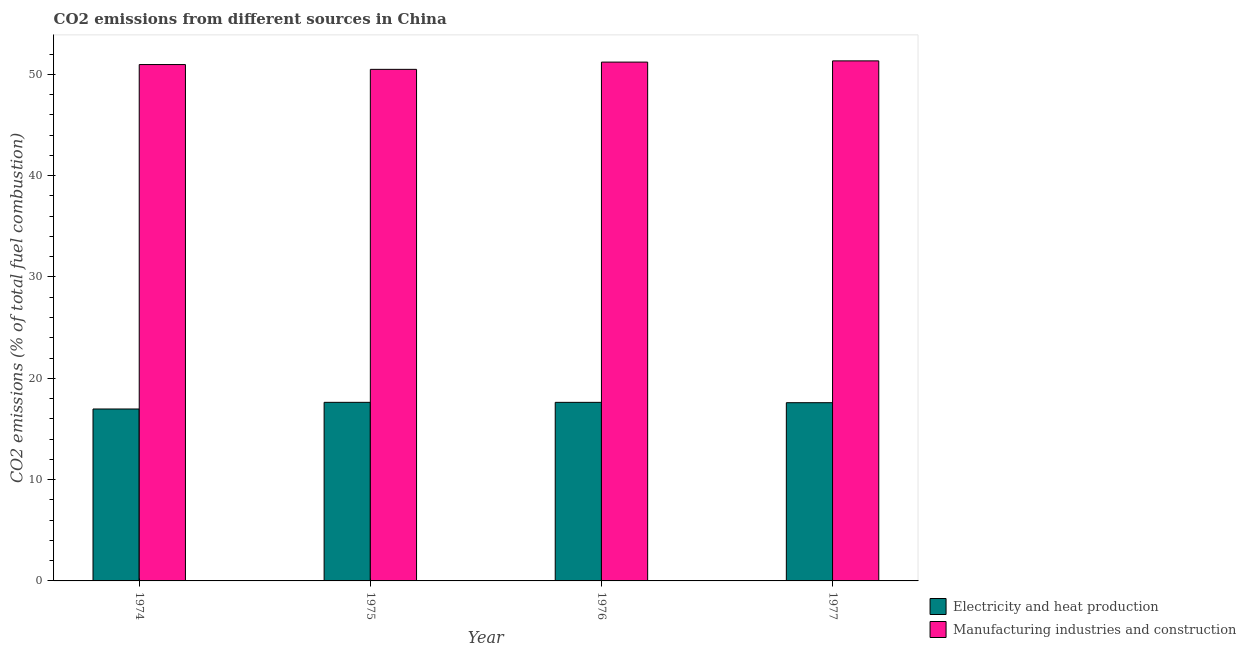How many different coloured bars are there?
Keep it short and to the point. 2. What is the label of the 3rd group of bars from the left?
Make the answer very short. 1976. What is the co2 emissions due to electricity and heat production in 1976?
Provide a succinct answer. 17.63. Across all years, what is the maximum co2 emissions due to manufacturing industries?
Offer a very short reply. 51.33. Across all years, what is the minimum co2 emissions due to manufacturing industries?
Ensure brevity in your answer.  50.49. In which year was the co2 emissions due to electricity and heat production maximum?
Offer a very short reply. 1975. In which year was the co2 emissions due to manufacturing industries minimum?
Ensure brevity in your answer.  1975. What is the total co2 emissions due to manufacturing industries in the graph?
Make the answer very short. 203.99. What is the difference between the co2 emissions due to electricity and heat production in 1974 and that in 1975?
Ensure brevity in your answer.  -0.66. What is the difference between the co2 emissions due to manufacturing industries in 1976 and the co2 emissions due to electricity and heat production in 1974?
Keep it short and to the point. 0.24. What is the average co2 emissions due to electricity and heat production per year?
Offer a terse response. 17.45. In the year 1976, what is the difference between the co2 emissions due to electricity and heat production and co2 emissions due to manufacturing industries?
Provide a short and direct response. 0. What is the ratio of the co2 emissions due to electricity and heat production in 1974 to that in 1977?
Make the answer very short. 0.96. Is the co2 emissions due to manufacturing industries in 1975 less than that in 1976?
Keep it short and to the point. Yes. Is the difference between the co2 emissions due to manufacturing industries in 1975 and 1977 greater than the difference between the co2 emissions due to electricity and heat production in 1975 and 1977?
Provide a short and direct response. No. What is the difference between the highest and the second highest co2 emissions due to electricity and heat production?
Your answer should be very brief. 0. What is the difference between the highest and the lowest co2 emissions due to manufacturing industries?
Ensure brevity in your answer.  0.84. What does the 2nd bar from the left in 1974 represents?
Your answer should be very brief. Manufacturing industries and construction. What does the 1st bar from the right in 1974 represents?
Provide a short and direct response. Manufacturing industries and construction. Does the graph contain any zero values?
Your response must be concise. No. Does the graph contain grids?
Offer a very short reply. No. How many legend labels are there?
Your response must be concise. 2. What is the title of the graph?
Keep it short and to the point. CO2 emissions from different sources in China. Does "Quasi money growth" appear as one of the legend labels in the graph?
Your answer should be very brief. No. What is the label or title of the Y-axis?
Provide a short and direct response. CO2 emissions (% of total fuel combustion). What is the CO2 emissions (% of total fuel combustion) of Electricity and heat production in 1974?
Give a very brief answer. 16.97. What is the CO2 emissions (% of total fuel combustion) of Manufacturing industries and construction in 1974?
Your answer should be very brief. 50.97. What is the CO2 emissions (% of total fuel combustion) in Electricity and heat production in 1975?
Ensure brevity in your answer.  17.63. What is the CO2 emissions (% of total fuel combustion) of Manufacturing industries and construction in 1975?
Provide a succinct answer. 50.49. What is the CO2 emissions (% of total fuel combustion) of Electricity and heat production in 1976?
Provide a succinct answer. 17.63. What is the CO2 emissions (% of total fuel combustion) in Manufacturing industries and construction in 1976?
Offer a terse response. 51.21. What is the CO2 emissions (% of total fuel combustion) of Electricity and heat production in 1977?
Keep it short and to the point. 17.59. What is the CO2 emissions (% of total fuel combustion) in Manufacturing industries and construction in 1977?
Your response must be concise. 51.33. Across all years, what is the maximum CO2 emissions (% of total fuel combustion) in Electricity and heat production?
Provide a succinct answer. 17.63. Across all years, what is the maximum CO2 emissions (% of total fuel combustion) in Manufacturing industries and construction?
Your response must be concise. 51.33. Across all years, what is the minimum CO2 emissions (% of total fuel combustion) in Electricity and heat production?
Offer a very short reply. 16.97. Across all years, what is the minimum CO2 emissions (% of total fuel combustion) in Manufacturing industries and construction?
Keep it short and to the point. 50.49. What is the total CO2 emissions (% of total fuel combustion) of Electricity and heat production in the graph?
Make the answer very short. 69.81. What is the total CO2 emissions (% of total fuel combustion) of Manufacturing industries and construction in the graph?
Your response must be concise. 203.99. What is the difference between the CO2 emissions (% of total fuel combustion) of Electricity and heat production in 1974 and that in 1975?
Give a very brief answer. -0.66. What is the difference between the CO2 emissions (% of total fuel combustion) in Manufacturing industries and construction in 1974 and that in 1975?
Make the answer very short. 0.47. What is the difference between the CO2 emissions (% of total fuel combustion) of Electricity and heat production in 1974 and that in 1976?
Give a very brief answer. -0.66. What is the difference between the CO2 emissions (% of total fuel combustion) in Manufacturing industries and construction in 1974 and that in 1976?
Your answer should be very brief. -0.24. What is the difference between the CO2 emissions (% of total fuel combustion) of Electricity and heat production in 1974 and that in 1977?
Your answer should be compact. -0.62. What is the difference between the CO2 emissions (% of total fuel combustion) in Manufacturing industries and construction in 1974 and that in 1977?
Offer a terse response. -0.36. What is the difference between the CO2 emissions (% of total fuel combustion) in Electricity and heat production in 1975 and that in 1976?
Your answer should be compact. 0. What is the difference between the CO2 emissions (% of total fuel combustion) in Manufacturing industries and construction in 1975 and that in 1976?
Provide a succinct answer. -0.71. What is the difference between the CO2 emissions (% of total fuel combustion) in Electricity and heat production in 1975 and that in 1977?
Your answer should be compact. 0.04. What is the difference between the CO2 emissions (% of total fuel combustion) of Manufacturing industries and construction in 1975 and that in 1977?
Ensure brevity in your answer.  -0.84. What is the difference between the CO2 emissions (% of total fuel combustion) in Electricity and heat production in 1976 and that in 1977?
Your answer should be compact. 0.04. What is the difference between the CO2 emissions (% of total fuel combustion) in Manufacturing industries and construction in 1976 and that in 1977?
Offer a terse response. -0.12. What is the difference between the CO2 emissions (% of total fuel combustion) of Electricity and heat production in 1974 and the CO2 emissions (% of total fuel combustion) of Manufacturing industries and construction in 1975?
Your answer should be very brief. -33.52. What is the difference between the CO2 emissions (% of total fuel combustion) of Electricity and heat production in 1974 and the CO2 emissions (% of total fuel combustion) of Manufacturing industries and construction in 1976?
Offer a very short reply. -34.24. What is the difference between the CO2 emissions (% of total fuel combustion) in Electricity and heat production in 1974 and the CO2 emissions (% of total fuel combustion) in Manufacturing industries and construction in 1977?
Provide a short and direct response. -34.36. What is the difference between the CO2 emissions (% of total fuel combustion) in Electricity and heat production in 1975 and the CO2 emissions (% of total fuel combustion) in Manufacturing industries and construction in 1976?
Provide a short and direct response. -33.58. What is the difference between the CO2 emissions (% of total fuel combustion) of Electricity and heat production in 1975 and the CO2 emissions (% of total fuel combustion) of Manufacturing industries and construction in 1977?
Offer a very short reply. -33.7. What is the difference between the CO2 emissions (% of total fuel combustion) of Electricity and heat production in 1976 and the CO2 emissions (% of total fuel combustion) of Manufacturing industries and construction in 1977?
Your answer should be compact. -33.7. What is the average CO2 emissions (% of total fuel combustion) of Electricity and heat production per year?
Keep it short and to the point. 17.45. What is the average CO2 emissions (% of total fuel combustion) in Manufacturing industries and construction per year?
Your answer should be very brief. 51. In the year 1974, what is the difference between the CO2 emissions (% of total fuel combustion) in Electricity and heat production and CO2 emissions (% of total fuel combustion) in Manufacturing industries and construction?
Your answer should be very brief. -34. In the year 1975, what is the difference between the CO2 emissions (% of total fuel combustion) in Electricity and heat production and CO2 emissions (% of total fuel combustion) in Manufacturing industries and construction?
Ensure brevity in your answer.  -32.87. In the year 1976, what is the difference between the CO2 emissions (% of total fuel combustion) in Electricity and heat production and CO2 emissions (% of total fuel combustion) in Manufacturing industries and construction?
Offer a very short reply. -33.58. In the year 1977, what is the difference between the CO2 emissions (% of total fuel combustion) in Electricity and heat production and CO2 emissions (% of total fuel combustion) in Manufacturing industries and construction?
Your answer should be compact. -33.74. What is the ratio of the CO2 emissions (% of total fuel combustion) of Electricity and heat production in 1974 to that in 1975?
Your answer should be very brief. 0.96. What is the ratio of the CO2 emissions (% of total fuel combustion) of Manufacturing industries and construction in 1974 to that in 1975?
Make the answer very short. 1.01. What is the ratio of the CO2 emissions (% of total fuel combustion) in Electricity and heat production in 1974 to that in 1976?
Offer a very short reply. 0.96. What is the ratio of the CO2 emissions (% of total fuel combustion) of Manufacturing industries and construction in 1974 to that in 1976?
Make the answer very short. 1. What is the ratio of the CO2 emissions (% of total fuel combustion) in Electricity and heat production in 1974 to that in 1977?
Keep it short and to the point. 0.96. What is the ratio of the CO2 emissions (% of total fuel combustion) of Electricity and heat production in 1975 to that in 1977?
Your answer should be very brief. 1. What is the ratio of the CO2 emissions (% of total fuel combustion) of Manufacturing industries and construction in 1975 to that in 1977?
Provide a succinct answer. 0.98. What is the ratio of the CO2 emissions (% of total fuel combustion) in Electricity and heat production in 1976 to that in 1977?
Provide a succinct answer. 1. What is the ratio of the CO2 emissions (% of total fuel combustion) of Manufacturing industries and construction in 1976 to that in 1977?
Provide a succinct answer. 1. What is the difference between the highest and the second highest CO2 emissions (% of total fuel combustion) of Electricity and heat production?
Your response must be concise. 0. What is the difference between the highest and the second highest CO2 emissions (% of total fuel combustion) in Manufacturing industries and construction?
Give a very brief answer. 0.12. What is the difference between the highest and the lowest CO2 emissions (% of total fuel combustion) of Electricity and heat production?
Ensure brevity in your answer.  0.66. What is the difference between the highest and the lowest CO2 emissions (% of total fuel combustion) in Manufacturing industries and construction?
Make the answer very short. 0.84. 